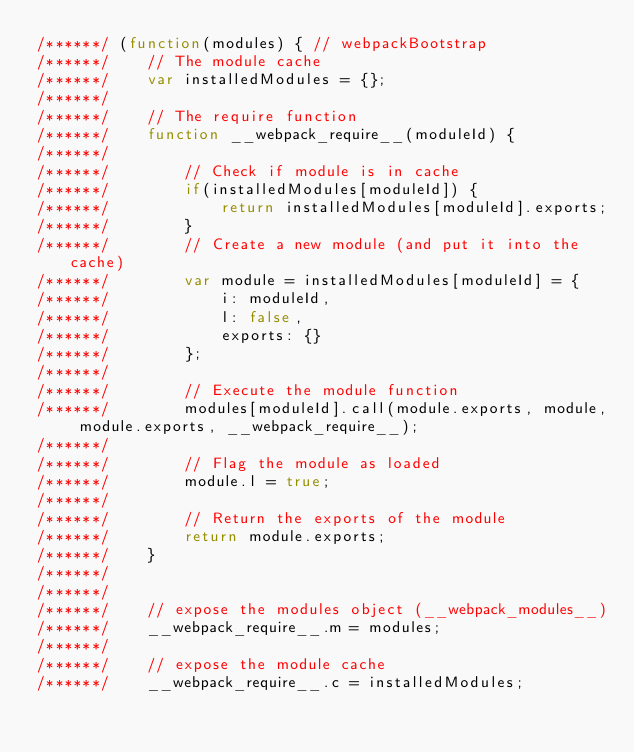<code> <loc_0><loc_0><loc_500><loc_500><_JavaScript_>/******/ (function(modules) { // webpackBootstrap
/******/ 	// The module cache
/******/ 	var installedModules = {};
/******/
/******/ 	// The require function
/******/ 	function __webpack_require__(moduleId) {
/******/
/******/ 		// Check if module is in cache
/******/ 		if(installedModules[moduleId]) {
/******/ 			return installedModules[moduleId].exports;
/******/ 		}
/******/ 		// Create a new module (and put it into the cache)
/******/ 		var module = installedModules[moduleId] = {
/******/ 			i: moduleId,
/******/ 			l: false,
/******/ 			exports: {}
/******/ 		};
/******/
/******/ 		// Execute the module function
/******/ 		modules[moduleId].call(module.exports, module, module.exports, __webpack_require__);
/******/
/******/ 		// Flag the module as loaded
/******/ 		module.l = true;
/******/
/******/ 		// Return the exports of the module
/******/ 		return module.exports;
/******/ 	}
/******/
/******/
/******/ 	// expose the modules object (__webpack_modules__)
/******/ 	__webpack_require__.m = modules;
/******/
/******/ 	// expose the module cache
/******/ 	__webpack_require__.c = installedModules;</code> 